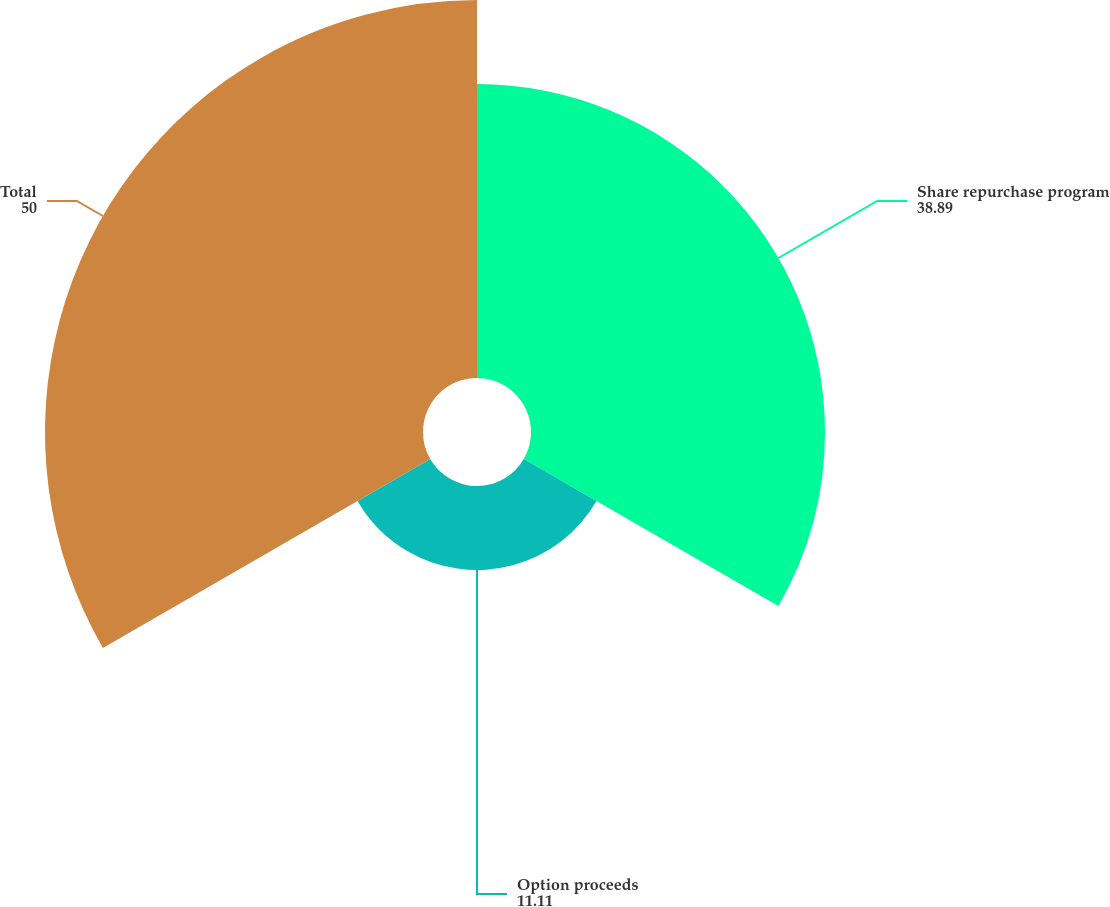Convert chart to OTSL. <chart><loc_0><loc_0><loc_500><loc_500><pie_chart><fcel>Share repurchase program<fcel>Option proceeds<fcel>Total<nl><fcel>38.89%<fcel>11.11%<fcel>50.0%<nl></chart> 